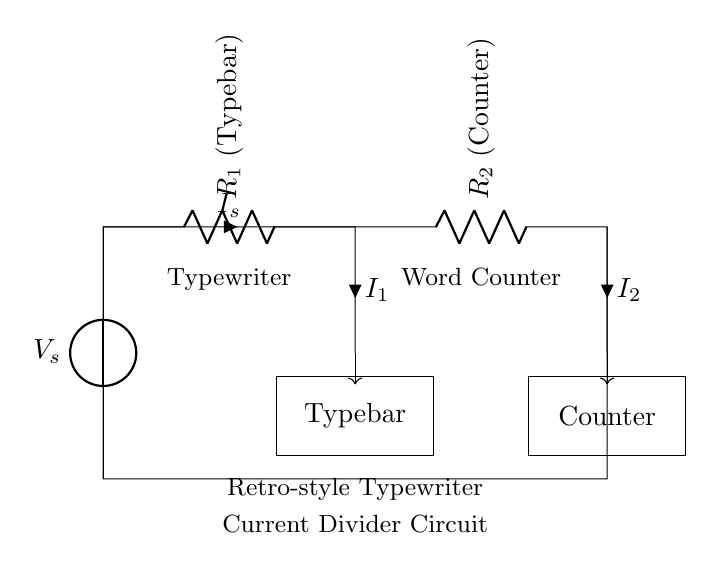What are the components present in the circuit? The components visible in the diagram are a voltage source, two resistors labeled as a typebar and a counter.
Answer: voltage source, typebar, counter What is the current flowing through the typebar? The current flowing through the typebar is represented as I1, which is one portion of the total current IS. The diagram indicates that the total current splits between the typebar and the counter.
Answer: I1 What type of circuit is displayed here? The circuit displayed is a current divider, where the current is split between two branches, leading to the typebar and the counter.
Answer: current divider How does the total current split between the typebar and the counter? The total current IS divides into two different currents, I1 through the typebar and I2 through the counter, based on the resistance. The lower the resistance, the higher the current through that component.
Answer: based on resistance What is the function of the word counter in this circuit? The word counter enhances the functionality of the typewriter by keeping track of the number of words typed. It is specifically assigned as one part of the current divider, receiving a portion of the current IS.
Answer: track words typed 